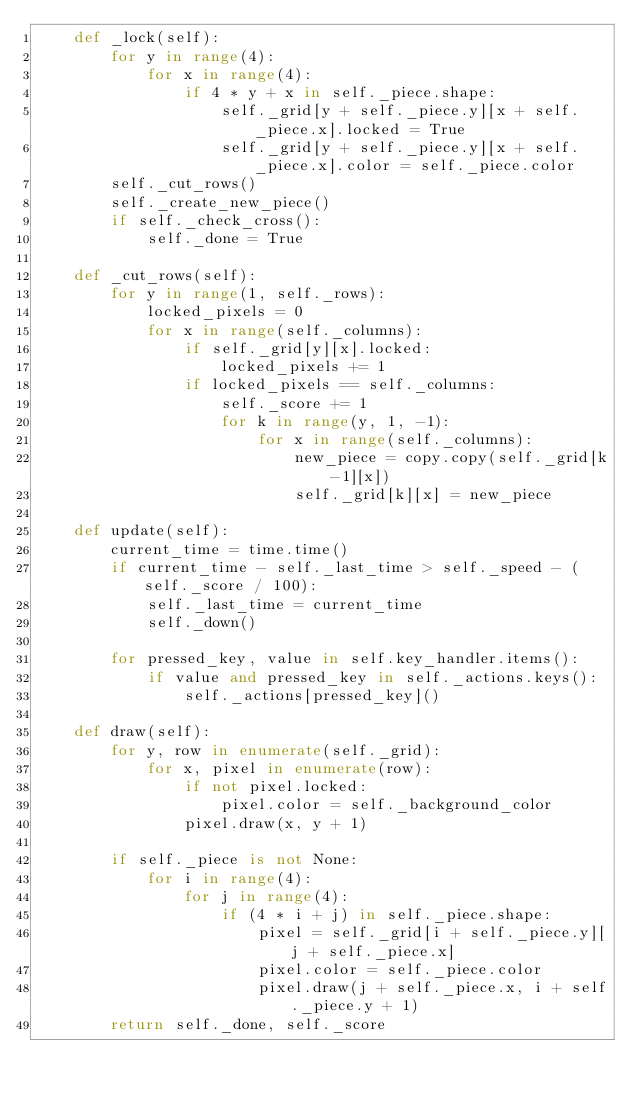Convert code to text. <code><loc_0><loc_0><loc_500><loc_500><_Python_>    def _lock(self):
        for y in range(4):
            for x in range(4):
                if 4 * y + x in self._piece.shape:
                    self._grid[y + self._piece.y][x + self._piece.x].locked = True
                    self._grid[y + self._piece.y][x + self._piece.x].color = self._piece.color
        self._cut_rows()
        self._create_new_piece()
        if self._check_cross():
            self._done = True

    def _cut_rows(self):
        for y in range(1, self._rows):
            locked_pixels = 0
            for x in range(self._columns):
                if self._grid[y][x].locked:
                    locked_pixels += 1
                if locked_pixels == self._columns:
                    self._score += 1
                    for k in range(y, 1, -1):
                        for x in range(self._columns):
                            new_piece = copy.copy(self._grid[k-1][x])
                            self._grid[k][x] = new_piece

    def update(self):
        current_time = time.time()
        if current_time - self._last_time > self._speed - (self._score / 100):
            self._last_time = current_time
            self._down()

        for pressed_key, value in self.key_handler.items():
            if value and pressed_key in self._actions.keys():
                self._actions[pressed_key]()

    def draw(self):
        for y, row in enumerate(self._grid):
            for x, pixel in enumerate(row):
                if not pixel.locked:
                    pixel.color = self._background_color
                pixel.draw(x, y + 1)

        if self._piece is not None:
            for i in range(4):
                for j in range(4):
                    if (4 * i + j) in self._piece.shape:
                        pixel = self._grid[i + self._piece.y][j + self._piece.x]
                        pixel.color = self._piece.color
                        pixel.draw(j + self._piece.x, i + self._piece.y + 1)
        return self._done, self._score
</code> 